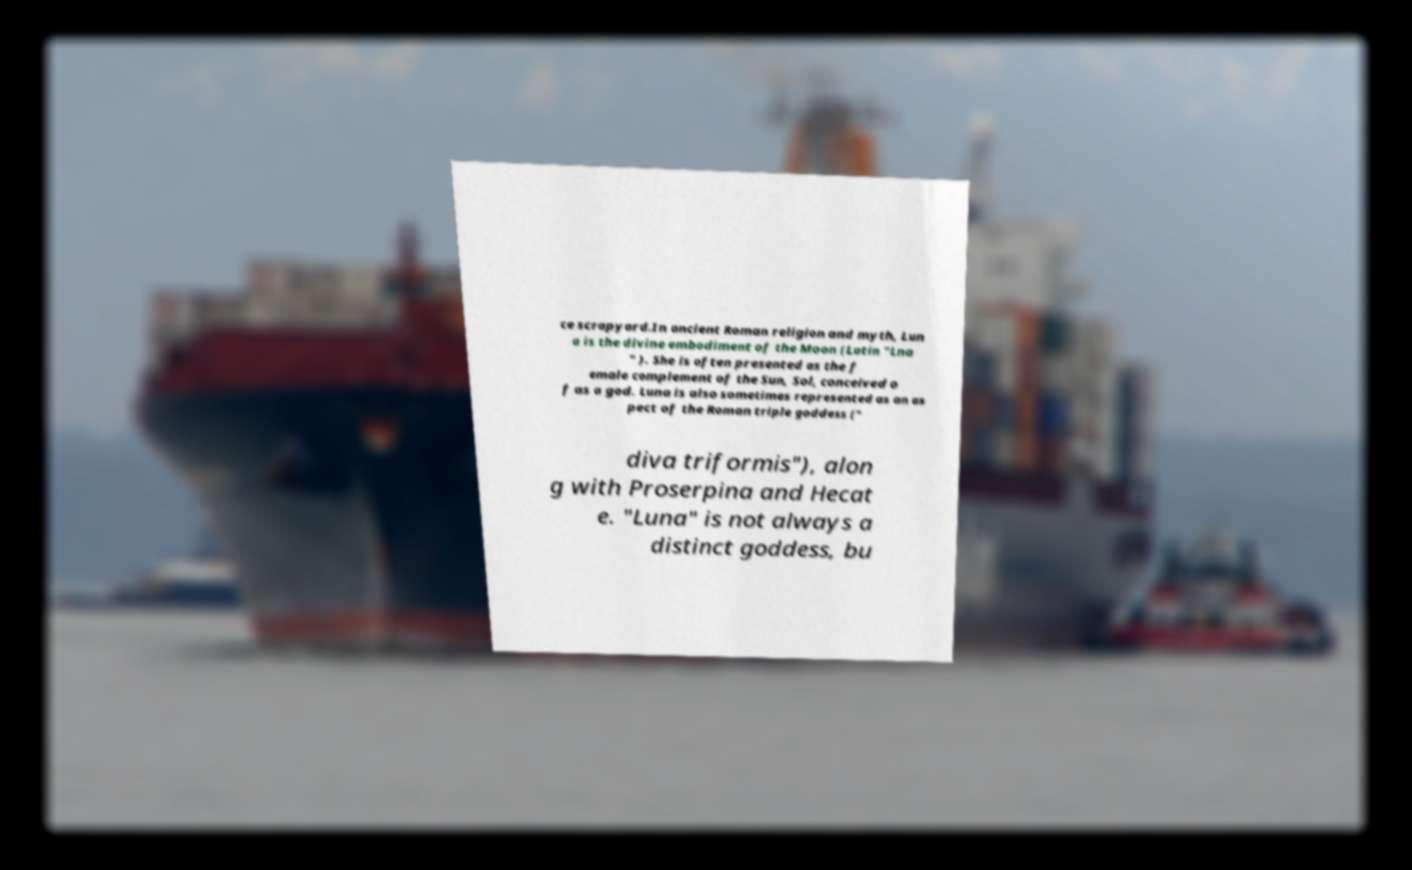Could you extract and type out the text from this image? ce scrapyard.In ancient Roman religion and myth, Lun a is the divine embodiment of the Moon (Latin "Lna " ). She is often presented as the f emale complement of the Sun, Sol, conceived o f as a god. Luna is also sometimes represented as an as pect of the Roman triple goddess (" diva triformis"), alon g with Proserpina and Hecat e. "Luna" is not always a distinct goddess, bu 